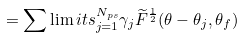<formula> <loc_0><loc_0><loc_500><loc_500>= \sum \lim i t s _ { j = 1 } ^ { N _ { p s } } \gamma _ { j } \widetilde { F } ^ { \frac { 1 } { 2 } } ( \theta - \theta _ { j } , \theta _ { f } )</formula> 